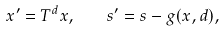<formula> <loc_0><loc_0><loc_500><loc_500>x ^ { \prime } = T ^ { d } x , \quad s ^ { \prime } = s - g ( x , d ) ,</formula> 